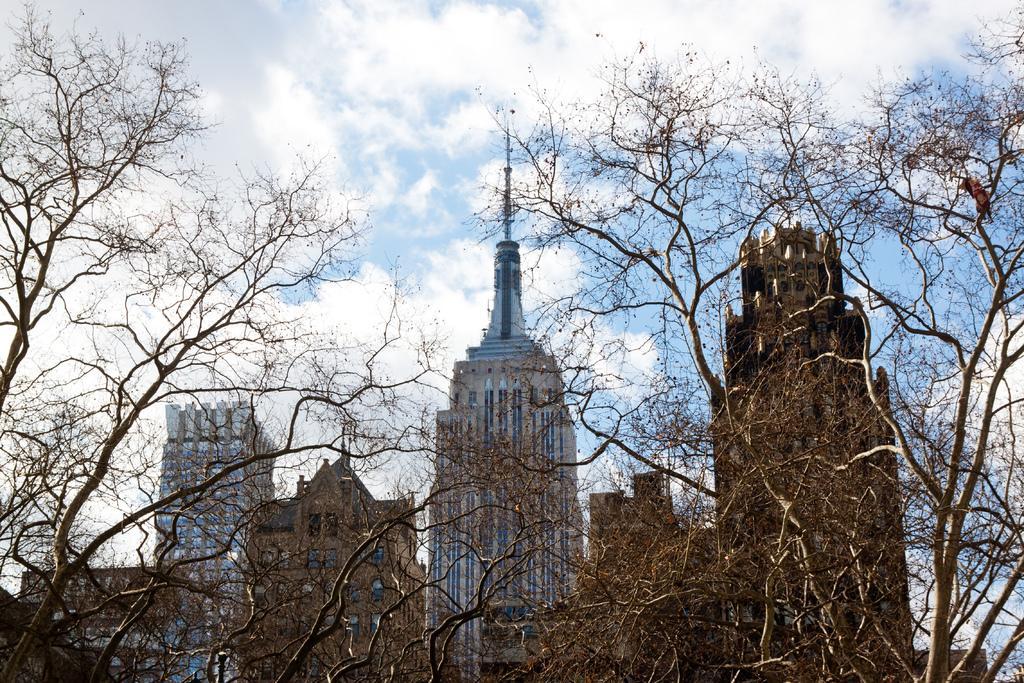In one or two sentences, can you explain what this image depicts? In this image in front there are trees. In the background of the image there are buildings and sky. 